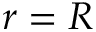Convert formula to latex. <formula><loc_0><loc_0><loc_500><loc_500>r = R</formula> 